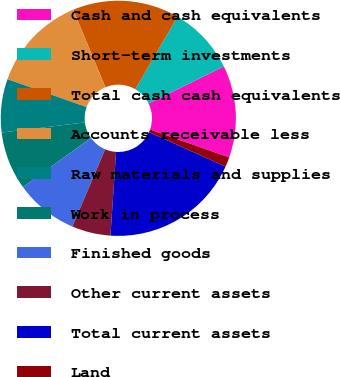<chart> <loc_0><loc_0><loc_500><loc_500><pie_chart><fcel>Cash and cash equivalents<fcel>Short-term investments<fcel>Total cash cash equivalents<fcel>Accounts receivable less<fcel>Raw materials and supplies<fcel>Work in process<fcel>Finished goods<fcel>Other current assets<fcel>Total current assets<fcel>Land<nl><fcel>12.67%<fcel>9.33%<fcel>14.67%<fcel>13.33%<fcel>7.33%<fcel>8.0%<fcel>8.67%<fcel>5.33%<fcel>19.33%<fcel>1.33%<nl></chart> 